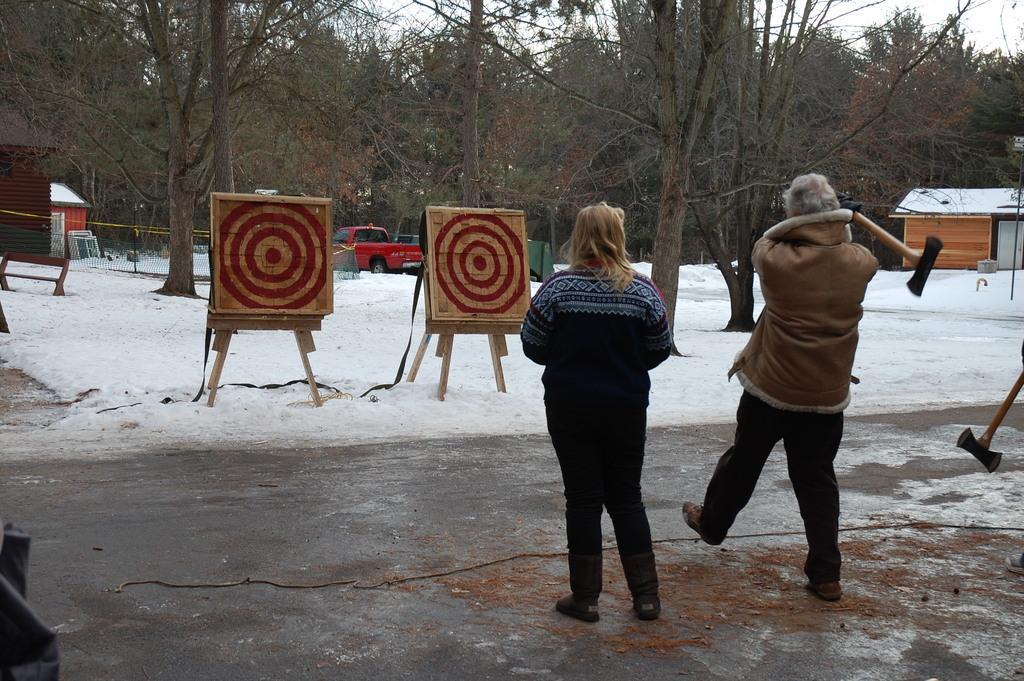Please provide a concise description of this image. This image consists of two persons. To the right, the person is throwing axe on the board. At the bottom, there is a road along with the snow. In the background, there are trees and small houses. 